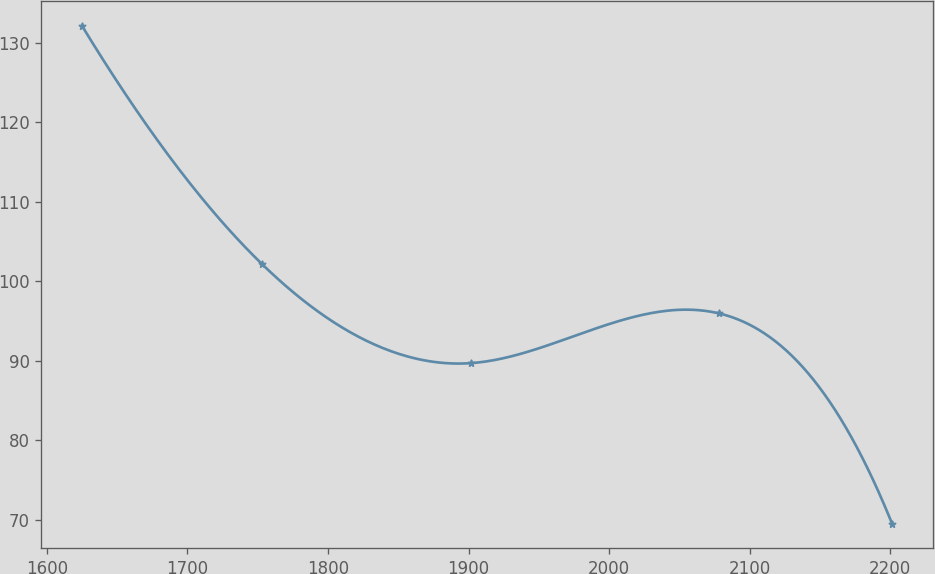Convert chart to OTSL. <chart><loc_0><loc_0><loc_500><loc_500><line_chart><ecel><fcel>Unnamed: 1<nl><fcel>1624.94<fcel>132.15<nl><fcel>1752.69<fcel>102.24<nl><fcel>1901.38<fcel>89.72<nl><fcel>2078.12<fcel>95.98<nl><fcel>2201.27<fcel>69.54<nl></chart> 